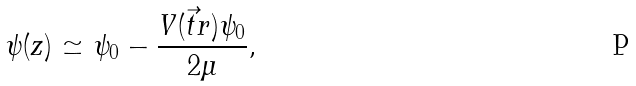<formula> <loc_0><loc_0><loc_500><loc_500>\psi ( z ) \simeq \psi _ { 0 } - \frac { V ( \vec { t } { r } ) \psi _ { 0 } } { 2 \mu } ,</formula> 